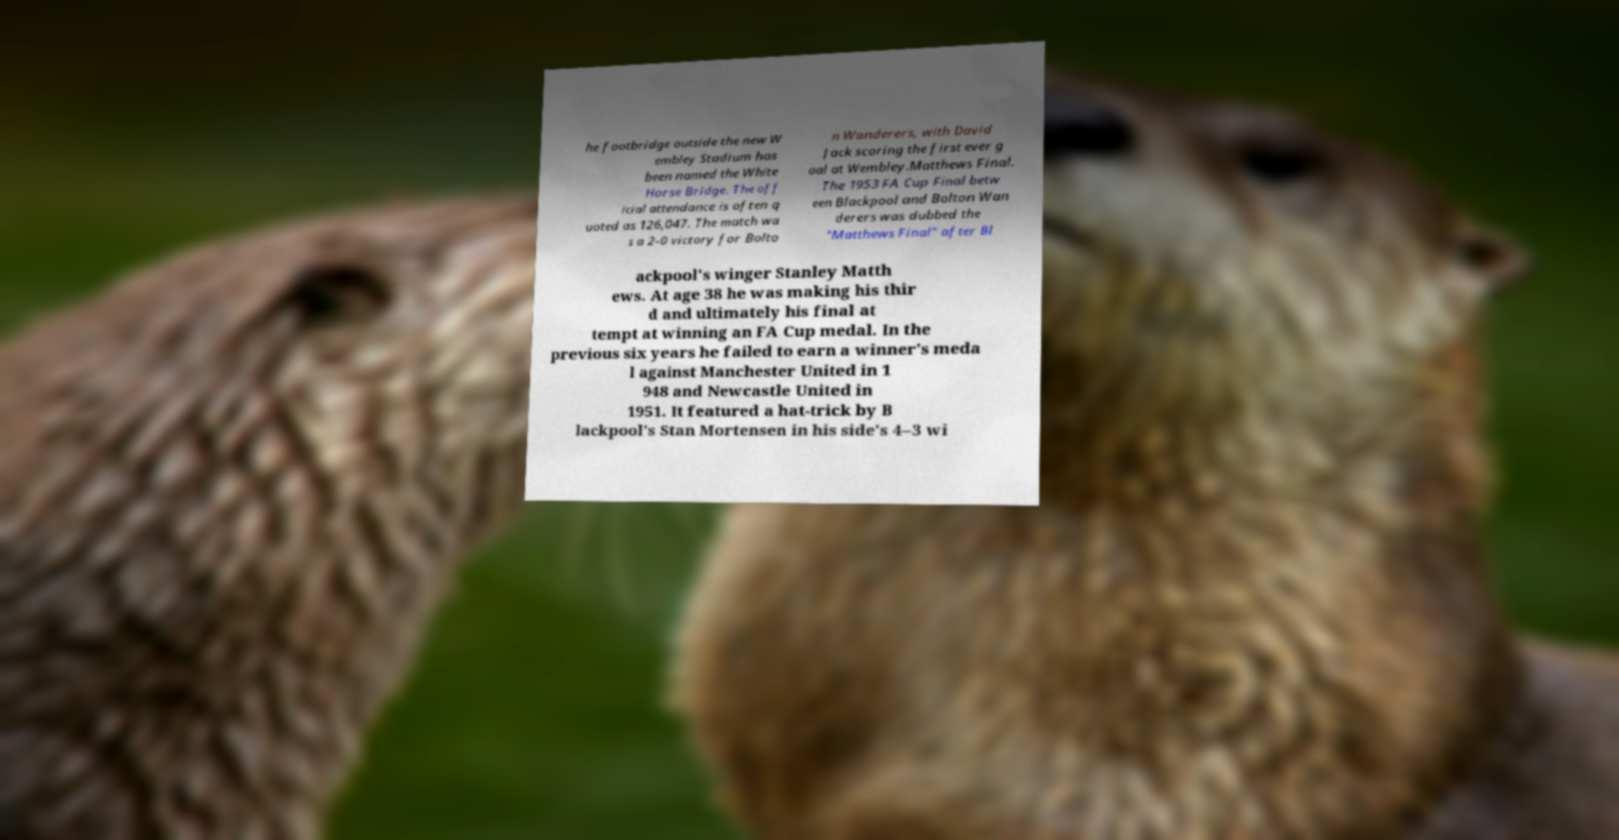Can you accurately transcribe the text from the provided image for me? he footbridge outside the new W embley Stadium has been named the White Horse Bridge. The off icial attendance is often q uoted as 126,047. The match wa s a 2–0 victory for Bolto n Wanderers, with David Jack scoring the first ever g oal at Wembley.Matthews Final. The 1953 FA Cup Final betw een Blackpool and Bolton Wan derers was dubbed the "Matthews Final" after Bl ackpool's winger Stanley Matth ews. At age 38 he was making his thir d and ultimately his final at tempt at winning an FA Cup medal. In the previous six years he failed to earn a winner's meda l against Manchester United in 1 948 and Newcastle United in 1951. It featured a hat-trick by B lackpool's Stan Mortensen in his side's 4–3 wi 